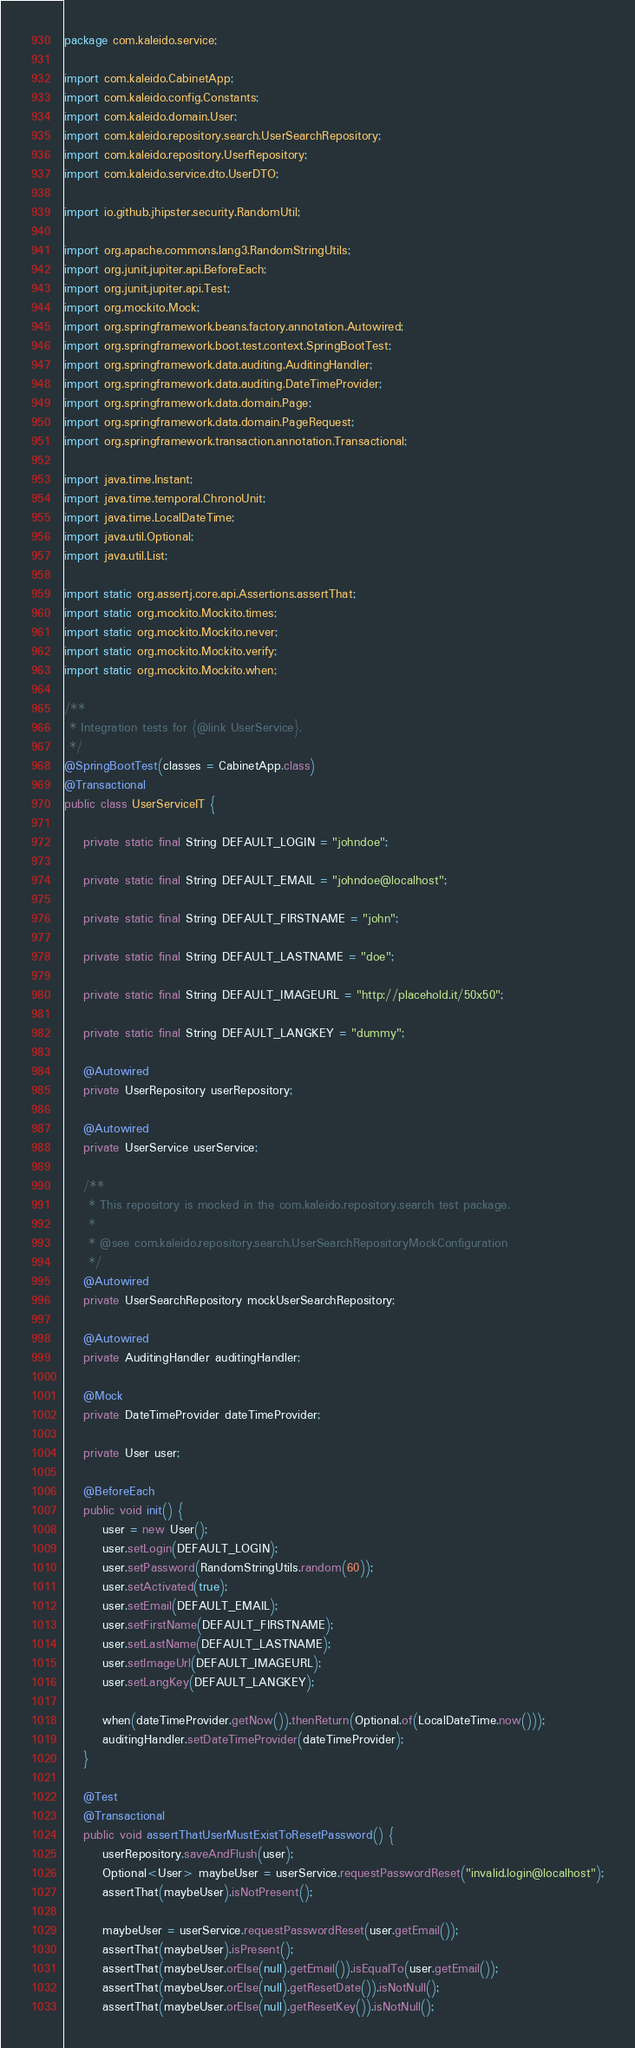Convert code to text. <code><loc_0><loc_0><loc_500><loc_500><_Java_>package com.kaleido.service;

import com.kaleido.CabinetApp;
import com.kaleido.config.Constants;
import com.kaleido.domain.User;
import com.kaleido.repository.search.UserSearchRepository;
import com.kaleido.repository.UserRepository;
import com.kaleido.service.dto.UserDTO;

import io.github.jhipster.security.RandomUtil;

import org.apache.commons.lang3.RandomStringUtils;
import org.junit.jupiter.api.BeforeEach;
import org.junit.jupiter.api.Test;
import org.mockito.Mock;
import org.springframework.beans.factory.annotation.Autowired;
import org.springframework.boot.test.context.SpringBootTest;
import org.springframework.data.auditing.AuditingHandler;
import org.springframework.data.auditing.DateTimeProvider;
import org.springframework.data.domain.Page;
import org.springframework.data.domain.PageRequest;
import org.springframework.transaction.annotation.Transactional;

import java.time.Instant;
import java.time.temporal.ChronoUnit;
import java.time.LocalDateTime;
import java.util.Optional;
import java.util.List;

import static org.assertj.core.api.Assertions.assertThat;
import static org.mockito.Mockito.times;
import static org.mockito.Mockito.never;
import static org.mockito.Mockito.verify;
import static org.mockito.Mockito.when;

/**
 * Integration tests for {@link UserService}.
 */
@SpringBootTest(classes = CabinetApp.class)
@Transactional
public class UserServiceIT {

    private static final String DEFAULT_LOGIN = "johndoe";

    private static final String DEFAULT_EMAIL = "johndoe@localhost";

    private static final String DEFAULT_FIRSTNAME = "john";

    private static final String DEFAULT_LASTNAME = "doe";

    private static final String DEFAULT_IMAGEURL = "http://placehold.it/50x50";

    private static final String DEFAULT_LANGKEY = "dummy";

    @Autowired
    private UserRepository userRepository;

    @Autowired
    private UserService userService;

    /**
     * This repository is mocked in the com.kaleido.repository.search test package.
     *
     * @see com.kaleido.repository.search.UserSearchRepositoryMockConfiguration
     */
    @Autowired
    private UserSearchRepository mockUserSearchRepository;

    @Autowired
    private AuditingHandler auditingHandler;

    @Mock
    private DateTimeProvider dateTimeProvider;

    private User user;

    @BeforeEach
    public void init() {
        user = new User();
        user.setLogin(DEFAULT_LOGIN);
        user.setPassword(RandomStringUtils.random(60));
        user.setActivated(true);
        user.setEmail(DEFAULT_EMAIL);
        user.setFirstName(DEFAULT_FIRSTNAME);
        user.setLastName(DEFAULT_LASTNAME);
        user.setImageUrl(DEFAULT_IMAGEURL);
        user.setLangKey(DEFAULT_LANGKEY);

        when(dateTimeProvider.getNow()).thenReturn(Optional.of(LocalDateTime.now()));
        auditingHandler.setDateTimeProvider(dateTimeProvider);
    }

    @Test
    @Transactional
    public void assertThatUserMustExistToResetPassword() {
        userRepository.saveAndFlush(user);
        Optional<User> maybeUser = userService.requestPasswordReset("invalid.login@localhost");
        assertThat(maybeUser).isNotPresent();

        maybeUser = userService.requestPasswordReset(user.getEmail());
        assertThat(maybeUser).isPresent();
        assertThat(maybeUser.orElse(null).getEmail()).isEqualTo(user.getEmail());
        assertThat(maybeUser.orElse(null).getResetDate()).isNotNull();
        assertThat(maybeUser.orElse(null).getResetKey()).isNotNull();</code> 